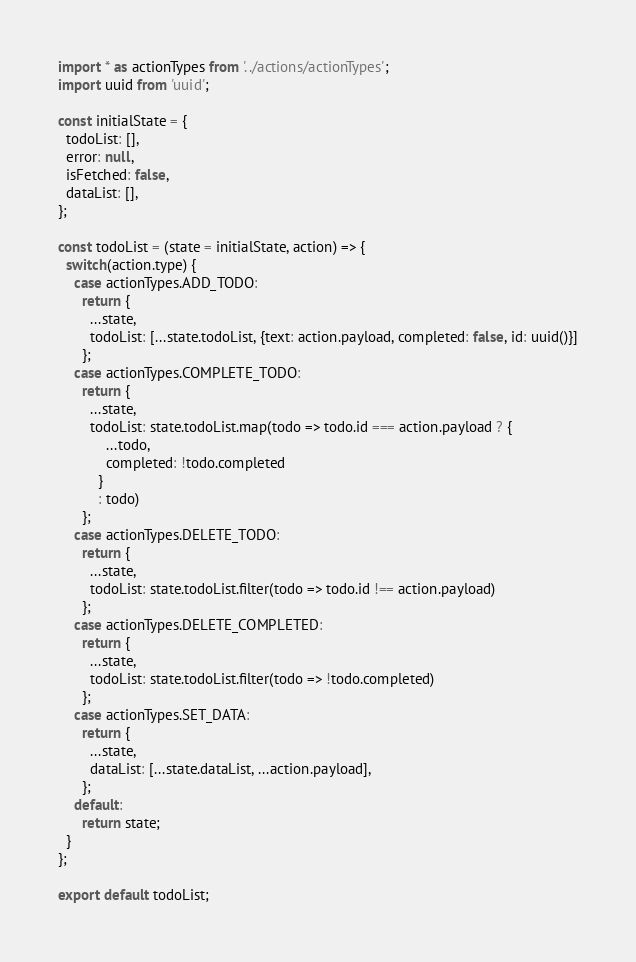Convert code to text. <code><loc_0><loc_0><loc_500><loc_500><_JavaScript_>import * as actionTypes from '../actions/actionTypes';
import uuid from 'uuid';

const initialState = {
  todoList: [],
  error: null,
  isFetched: false,
  dataList: [],
};

const todoList = (state = initialState, action) => {
  switch(action.type) {
    case actionTypes.ADD_TODO:
      return {
        ...state,
        todoList: [...state.todoList, {text: action.payload, completed: false, id: uuid()}]
      };
    case actionTypes.COMPLETE_TODO:
      return {
        ...state,
        todoList: state.todoList.map(todo => todo.id === action.payload ? {
            ...todo,
            completed: !todo.completed
          }
          : todo)
      };
    case actionTypes.DELETE_TODO:
      return {
        ...state,
        todoList: state.todoList.filter(todo => todo.id !== action.payload)
      };
    case actionTypes.DELETE_COMPLETED:
      return {
        ...state,
        todoList: state.todoList.filter(todo => !todo.completed)
      };
    case actionTypes.SET_DATA:
      return {
        ...state,
        dataList: [...state.dataList, ...action.payload],
      };
    default:
      return state;
  }
};

export default todoList;</code> 